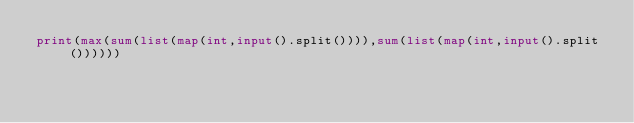<code> <loc_0><loc_0><loc_500><loc_500><_Python_>print(max(sum(list(map(int,input().split()))),sum(list(map(int,input().split())))))
</code> 